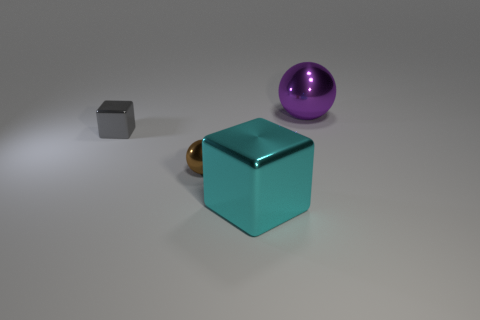Add 4 brown rubber balls. How many objects exist? 8 Add 3 cyan objects. How many cyan objects exist? 4 Subtract 0 gray balls. How many objects are left? 4 Subtract all big cyan metallic blocks. Subtract all tiny balls. How many objects are left? 2 Add 4 brown metal objects. How many brown metal objects are left? 5 